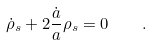Convert formula to latex. <formula><loc_0><loc_0><loc_500><loc_500>\dot { \rho } _ { s } + 2 \frac { \dot { a } } { a } \rho _ { s } = 0 \quad .</formula> 